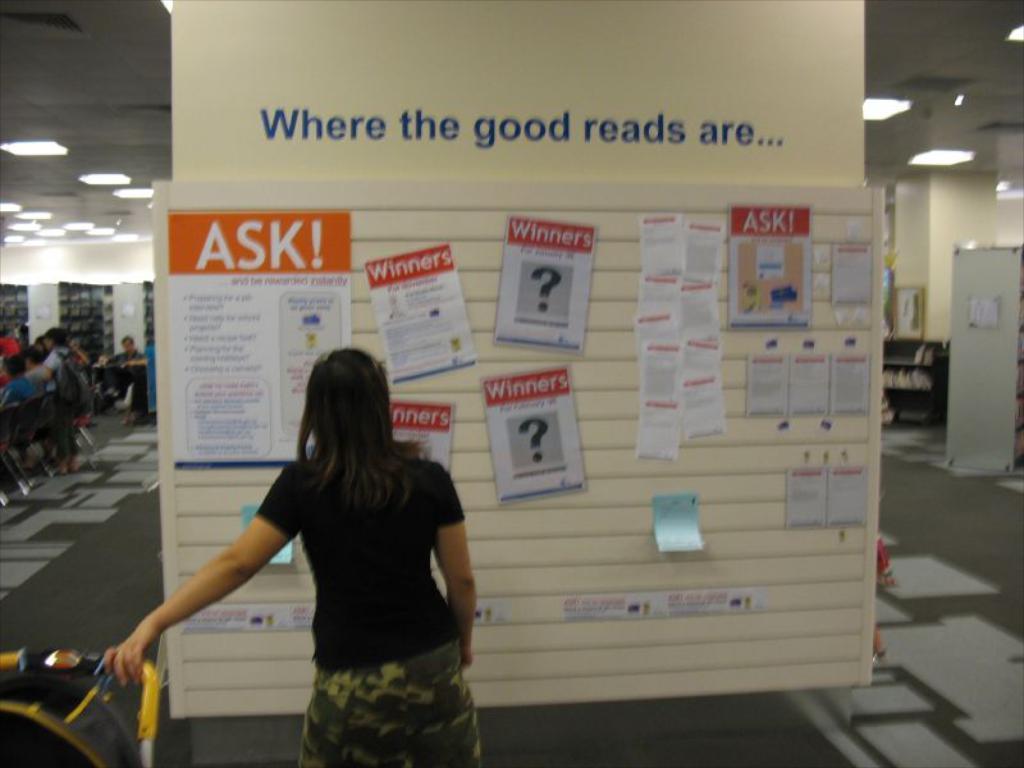In one or two sentences, can you explain what this image depicts? In the image I can see people among them the person in the front is standing. I can also see a board which has some papers and other objects attached to it. In the background I can see lights on the ceiling and some other objects on the floor. 